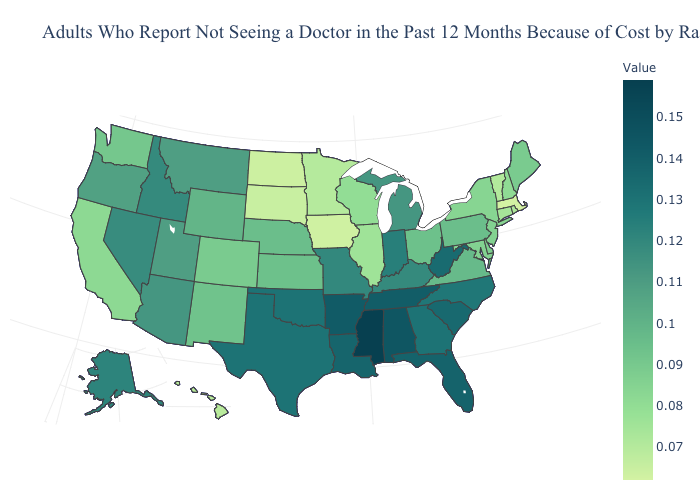Does Mississippi have the highest value in the USA?
Keep it brief. Yes. Among the states that border Kentucky , does Tennessee have the lowest value?
Give a very brief answer. No. Does Massachusetts have the lowest value in the Northeast?
Be succinct. Yes. Among the states that border Illinois , does Kentucky have the lowest value?
Quick response, please. No. Does the map have missing data?
Answer briefly. No. Among the states that border Rhode Island , does Massachusetts have the lowest value?
Give a very brief answer. Yes. Does Maryland have a higher value than Georgia?
Be succinct. No. Among the states that border Connecticut , which have the highest value?
Write a very short answer. New York. 